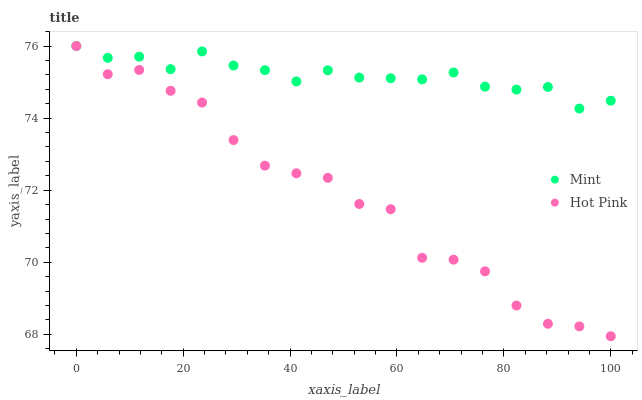Does Hot Pink have the minimum area under the curve?
Answer yes or no. Yes. Does Mint have the maximum area under the curve?
Answer yes or no. Yes. Does Mint have the minimum area under the curve?
Answer yes or no. No. Is Mint the smoothest?
Answer yes or no. Yes. Is Hot Pink the roughest?
Answer yes or no. Yes. Is Mint the roughest?
Answer yes or no. No. Does Hot Pink have the lowest value?
Answer yes or no. Yes. Does Mint have the lowest value?
Answer yes or no. No. Does Mint have the highest value?
Answer yes or no. Yes. Does Hot Pink intersect Mint?
Answer yes or no. Yes. Is Hot Pink less than Mint?
Answer yes or no. No. Is Hot Pink greater than Mint?
Answer yes or no. No. 